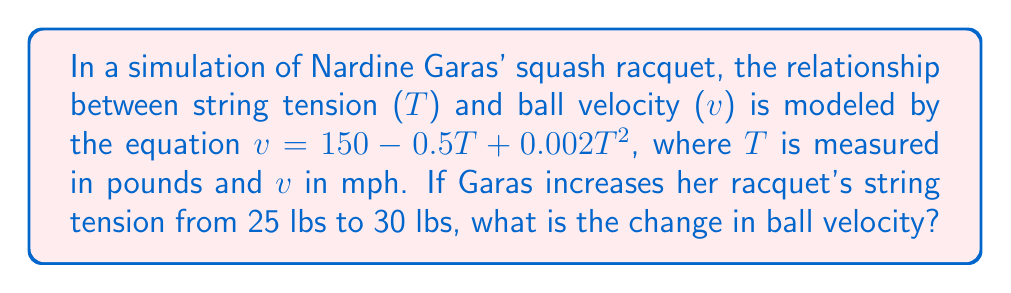Show me your answer to this math problem. To solve this problem, we need to follow these steps:

1) Calculate the velocity at 25 lbs tension:
   $v_{25} = 150 - 0.5(25) + 0.002(25)^2$
   $v_{25} = 150 - 12.5 + 0.002(625)$
   $v_{25} = 150 - 12.5 + 1.25$
   $v_{25} = 138.75$ mph

2) Calculate the velocity at 30 lbs tension:
   $v_{30} = 150 - 0.5(30) + 0.002(30)^2$
   $v_{30} = 150 - 15 + 0.002(900)$
   $v_{30} = 150 - 15 + 1.8$
   $v_{30} = 136.8$ mph

3) Calculate the change in velocity:
   $\Delta v = v_{30} - v_{25}$
   $\Delta v = 136.8 - 138.75$
   $\Delta v = -1.95$ mph

The negative value indicates a decrease in velocity.
Answer: $-1.95$ mph 